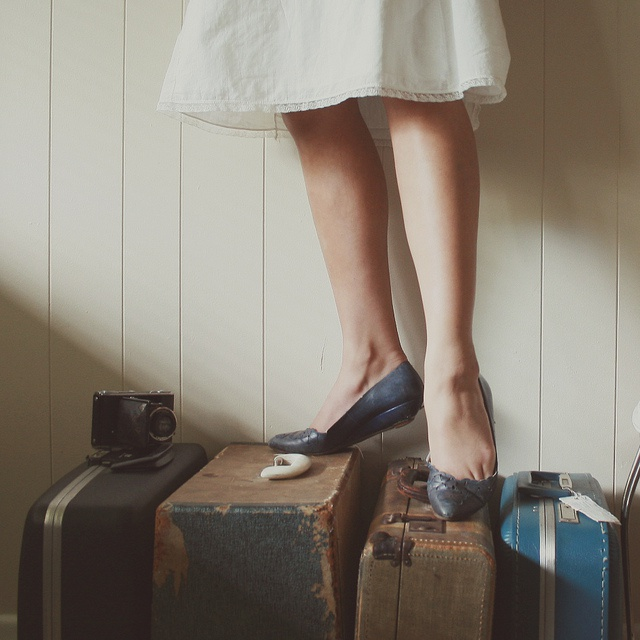Describe the objects in this image and their specific colors. I can see people in darkgray, lightgray, and gray tones, suitcase in darkgray, black, and gray tones, suitcase in darkgray, black, and gray tones, suitcase in darkgray, maroon, black, and gray tones, and suitcase in darkgray, black, blue, and gray tones in this image. 